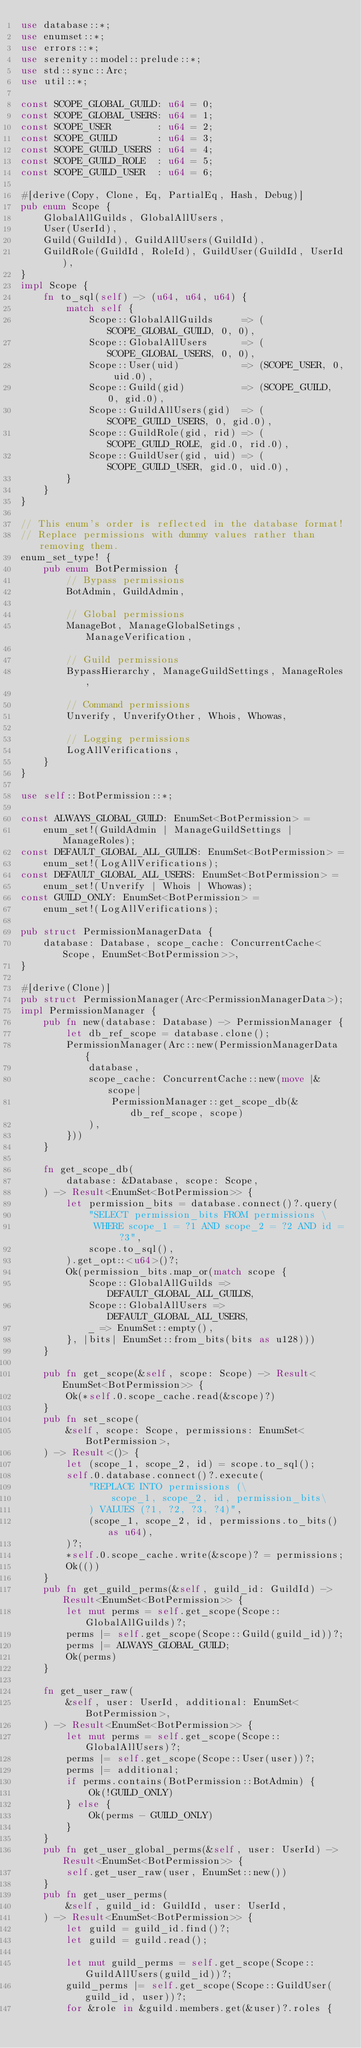Convert code to text. <code><loc_0><loc_0><loc_500><loc_500><_Rust_>use database::*;
use enumset::*;
use errors::*;
use serenity::model::prelude::*;
use std::sync::Arc;
use util::*;

const SCOPE_GLOBAL_GUILD: u64 = 0;
const SCOPE_GLOBAL_USERS: u64 = 1;
const SCOPE_USER        : u64 = 2;
const SCOPE_GUILD       : u64 = 3;
const SCOPE_GUILD_USERS : u64 = 4;
const SCOPE_GUILD_ROLE  : u64 = 5;
const SCOPE_GUILD_USER  : u64 = 6;

#[derive(Copy, Clone, Eq, PartialEq, Hash, Debug)]
pub enum Scope {
    GlobalAllGuilds, GlobalAllUsers,
    User(UserId),
    Guild(GuildId), GuildAllUsers(GuildId),
    GuildRole(GuildId, RoleId), GuildUser(GuildId, UserId),
}
impl Scope {
    fn to_sql(self) -> (u64, u64, u64) {
        match self {
            Scope::GlobalAllGuilds     => (SCOPE_GLOBAL_GUILD, 0, 0),
            Scope::GlobalAllUsers      => (SCOPE_GLOBAL_USERS, 0, 0),
            Scope::User(uid)           => (SCOPE_USER, 0, uid.0),
            Scope::Guild(gid)          => (SCOPE_GUILD, 0, gid.0),
            Scope::GuildAllUsers(gid)  => (SCOPE_GUILD_USERS, 0, gid.0),
            Scope::GuildRole(gid, rid) => (SCOPE_GUILD_ROLE, gid.0, rid.0),
            Scope::GuildUser(gid, uid) => (SCOPE_GUILD_USER, gid.0, uid.0),
        }
    }
}

// This enum's order is reflected in the database format!
// Replace permissions with dummy values rather than removing them.
enum_set_type! {
    pub enum BotPermission {
        // Bypass permissions
        BotAdmin, GuildAdmin,

        // Global permissions
        ManageBot, ManageGlobalSetings, ManageVerification,

        // Guild permissions
        BypassHierarchy, ManageGuildSettings, ManageRoles,

        // Command permissions
        Unverify, UnverifyOther, Whois, Whowas,

        // Logging permissions
        LogAllVerifications,
    }
}

use self::BotPermission::*;

const ALWAYS_GLOBAL_GUILD: EnumSet<BotPermission> =
    enum_set!(GuildAdmin | ManageGuildSettings | ManageRoles);
const DEFAULT_GLOBAL_ALL_GUILDS: EnumSet<BotPermission> =
    enum_set!(LogAllVerifications);
const DEFAULT_GLOBAL_ALL_USERS: EnumSet<BotPermission> =
    enum_set!(Unverify | Whois | Whowas);
const GUILD_ONLY: EnumSet<BotPermission> =
    enum_set!(LogAllVerifications);

pub struct PermissionManagerData {
    database: Database, scope_cache: ConcurrentCache<Scope, EnumSet<BotPermission>>,
}

#[derive(Clone)]
pub struct PermissionManager(Arc<PermissionManagerData>);
impl PermissionManager {
    pub fn new(database: Database) -> PermissionManager {
        let db_ref_scope = database.clone();
        PermissionManager(Arc::new(PermissionManagerData {
            database,
            scope_cache: ConcurrentCache::new(move |&scope|
                PermissionManager::get_scope_db(&db_ref_scope, scope)
            ),
        }))
    }

    fn get_scope_db(
        database: &Database, scope: Scope,
    ) -> Result<EnumSet<BotPermission>> {
        let permission_bits = database.connect()?.query(
            "SELECT permission_bits FROM permissions \
             WHERE scope_1 = ?1 AND scope_2 = ?2 AND id = ?3",
            scope.to_sql(),
        ).get_opt::<u64>()?;
        Ok(permission_bits.map_or(match scope {
            Scope::GlobalAllGuilds => DEFAULT_GLOBAL_ALL_GUILDS,
            Scope::GlobalAllUsers => DEFAULT_GLOBAL_ALL_USERS,
            _ => EnumSet::empty(),
        }, |bits| EnumSet::from_bits(bits as u128)))
    }

    pub fn get_scope(&self, scope: Scope) -> Result<EnumSet<BotPermission>> {
        Ok(*self.0.scope_cache.read(&scope)?)
    }
    pub fn set_scope(
        &self, scope: Scope, permissions: EnumSet<BotPermission>,
    ) -> Result<()> {
        let (scope_1, scope_2, id) = scope.to_sql();
        self.0.database.connect()?.execute(
            "REPLACE INTO permissions (\
                scope_1, scope_2, id, permission_bits\
            ) VALUES (?1, ?2, ?3, ?4)",
            (scope_1, scope_2, id, permissions.to_bits() as u64),
        )?;
        *self.0.scope_cache.write(&scope)? = permissions;
        Ok(())
    }
    pub fn get_guild_perms(&self, guild_id: GuildId) -> Result<EnumSet<BotPermission>> {
        let mut perms = self.get_scope(Scope::GlobalAllGuilds)?;
        perms |= self.get_scope(Scope::Guild(guild_id))?;
        perms |= ALWAYS_GLOBAL_GUILD;
        Ok(perms)
    }

    fn get_user_raw(
        &self, user: UserId, additional: EnumSet<BotPermission>,
    ) -> Result<EnumSet<BotPermission>> {
        let mut perms = self.get_scope(Scope::GlobalAllUsers)?;
        perms |= self.get_scope(Scope::User(user))?;
        perms |= additional;
        if perms.contains(BotPermission::BotAdmin) {
            Ok(!GUILD_ONLY)
        } else {
            Ok(perms - GUILD_ONLY)
        }
    }
    pub fn get_user_global_perms(&self, user: UserId) -> Result<EnumSet<BotPermission>> {
        self.get_user_raw(user, EnumSet::new())
    }
    pub fn get_user_perms(
        &self, guild_id: GuildId, user: UserId,
    ) -> Result<EnumSet<BotPermission>> {
        let guild = guild_id.find()?;
        let guild = guild.read();

        let mut guild_perms = self.get_scope(Scope::GuildAllUsers(guild_id))?;
        guild_perms |= self.get_scope(Scope::GuildUser(guild_id, user))?;
        for &role in &guild.members.get(&user)?.roles {</code> 